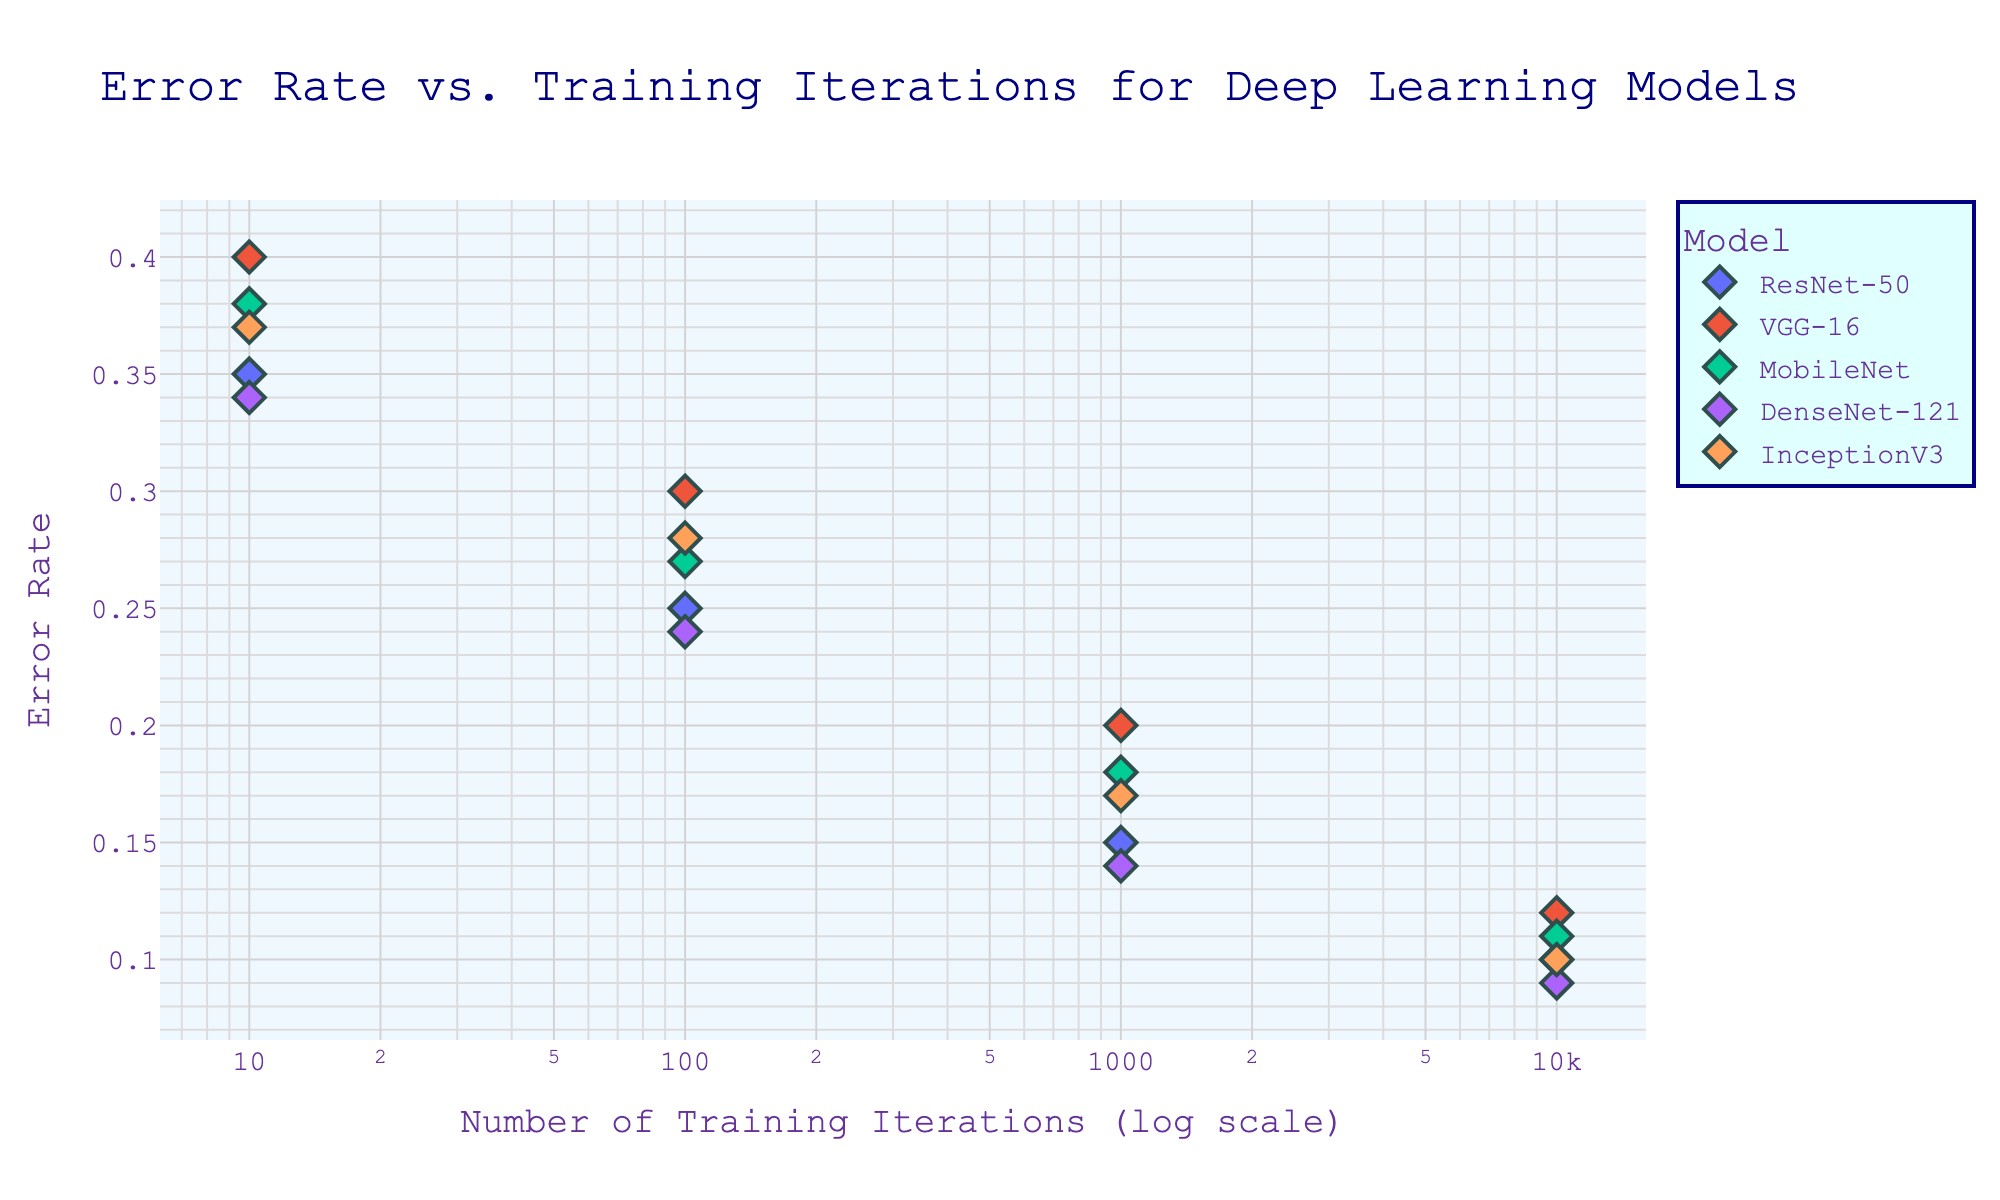What's the title of the scatter plot? The title is displayed at the top of the figure in large font.
Answer: Error Rate vs. Training Iterations for Deep Learning Models What is the x-axis label? The x-axis label is displayed beneath the horizontal axis of the figure in a readable font.
Answer: Number of Training Iterations (log scale) Which model has the lowest error rate at 10,000 iterations? We look at the data points for each model at 10,000 iterations and compare their error rates. DenseNet-121 has the lowest error rate (0.09).
Answer: DenseNet-121 How does the error rate for VGG-16 change from 10 to 10,000 iterations? We track the data points for VGG-16: 0.40 at 10 iterations, 0.30 at 100 iterations, 0.20 at 1,000 iterations, and 0.12 at 10,000 iterations. The error rate decreases as the number of iterations increases.
Answer: It decreases Compare the error rate of MobileNet and ResNet-50 at 1,000 iterations. We identify the data points at 1,000 iterations for both models and compare their error rates: MobileNet has an error rate of 0.18 and ResNet-50 has 0.15.
Answer: ResNet-50 has a lower error rate Which model shows the fastest improvement in error rate between 10 and 100 iterations? We calculate the reduction in error rate for each model between 10 and 100 iterations. The differences are: ResNet-50 (0.10), VGG-16 (0.10), MobileNet (0.11), DenseNet-121 (0.10), InceptionV3 (0.09). The smallest reduction (fastest improvement) is by MobileNet.
Answer: MobileNet How many data points are there in total for all models combined? We count the data points for each model and then sum them. There are 5 models, each with 4 data points. 5 * 4 = 20
Answer: 20 What is the error rate range for DenseNet-121? We find the lowest and the highest error rates for DenseNet-121: 0.09 (lowest) and 0.34 (highest).
Answer: 0.09 to 0.34 Which model has the least decrease in error rate between 1,000 and 10,000 iterations? We calculate the decrease in error rate for each model between 1,000 and 10,000 iterations. The differences are: ResNet-50 (0.05), VGG-16 (0.08), MobileNet (0.07), DenseNet-121 (0.05), InceptionV3 (0.07). DenseNet-121 has the least decrease.
Answer: DenseNet-121 